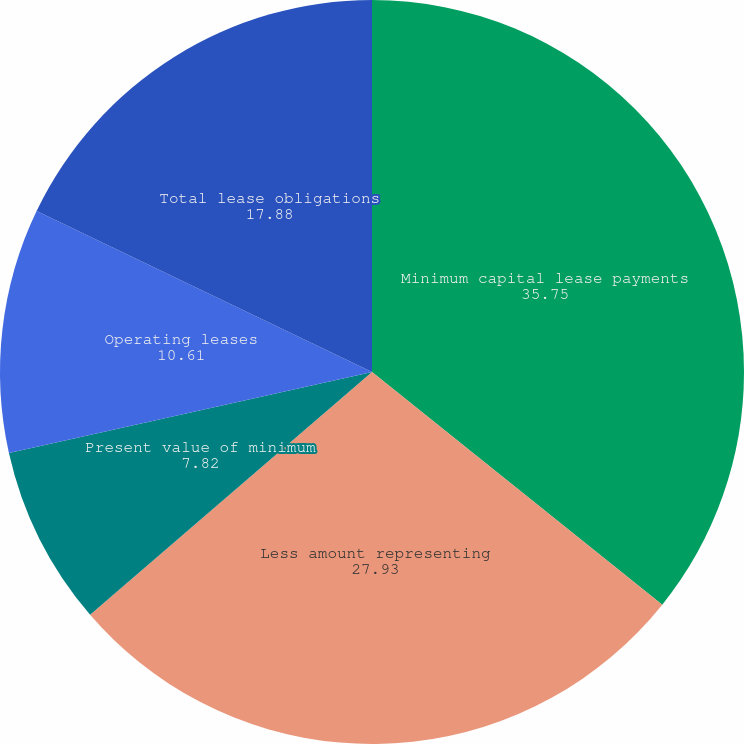Convert chart. <chart><loc_0><loc_0><loc_500><loc_500><pie_chart><fcel>Minimum capital lease payments<fcel>Less amount representing<fcel>Present value of minimum<fcel>Operating leases<fcel>Total lease obligations<nl><fcel>35.75%<fcel>27.93%<fcel>7.82%<fcel>10.61%<fcel>17.88%<nl></chart> 